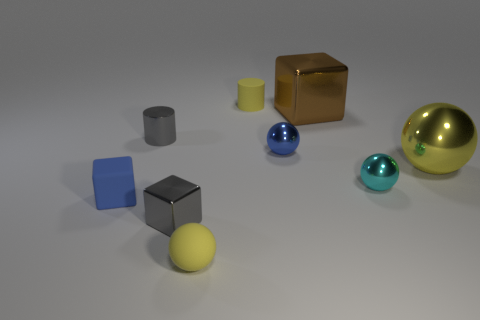Subtract all gray shiny blocks. How many blocks are left? 2 Add 1 large blue matte objects. How many objects exist? 10 Subtract all blue spheres. How many spheres are left? 3 Subtract all brown cylinders. How many yellow balls are left? 2 Subtract 3 balls. How many balls are left? 1 Add 8 tiny cyan metal balls. How many tiny cyan metal balls exist? 9 Subtract 0 cyan cylinders. How many objects are left? 9 Subtract all balls. How many objects are left? 5 Subtract all green blocks. Subtract all brown balls. How many blocks are left? 3 Subtract all large matte objects. Subtract all blue rubber cubes. How many objects are left? 8 